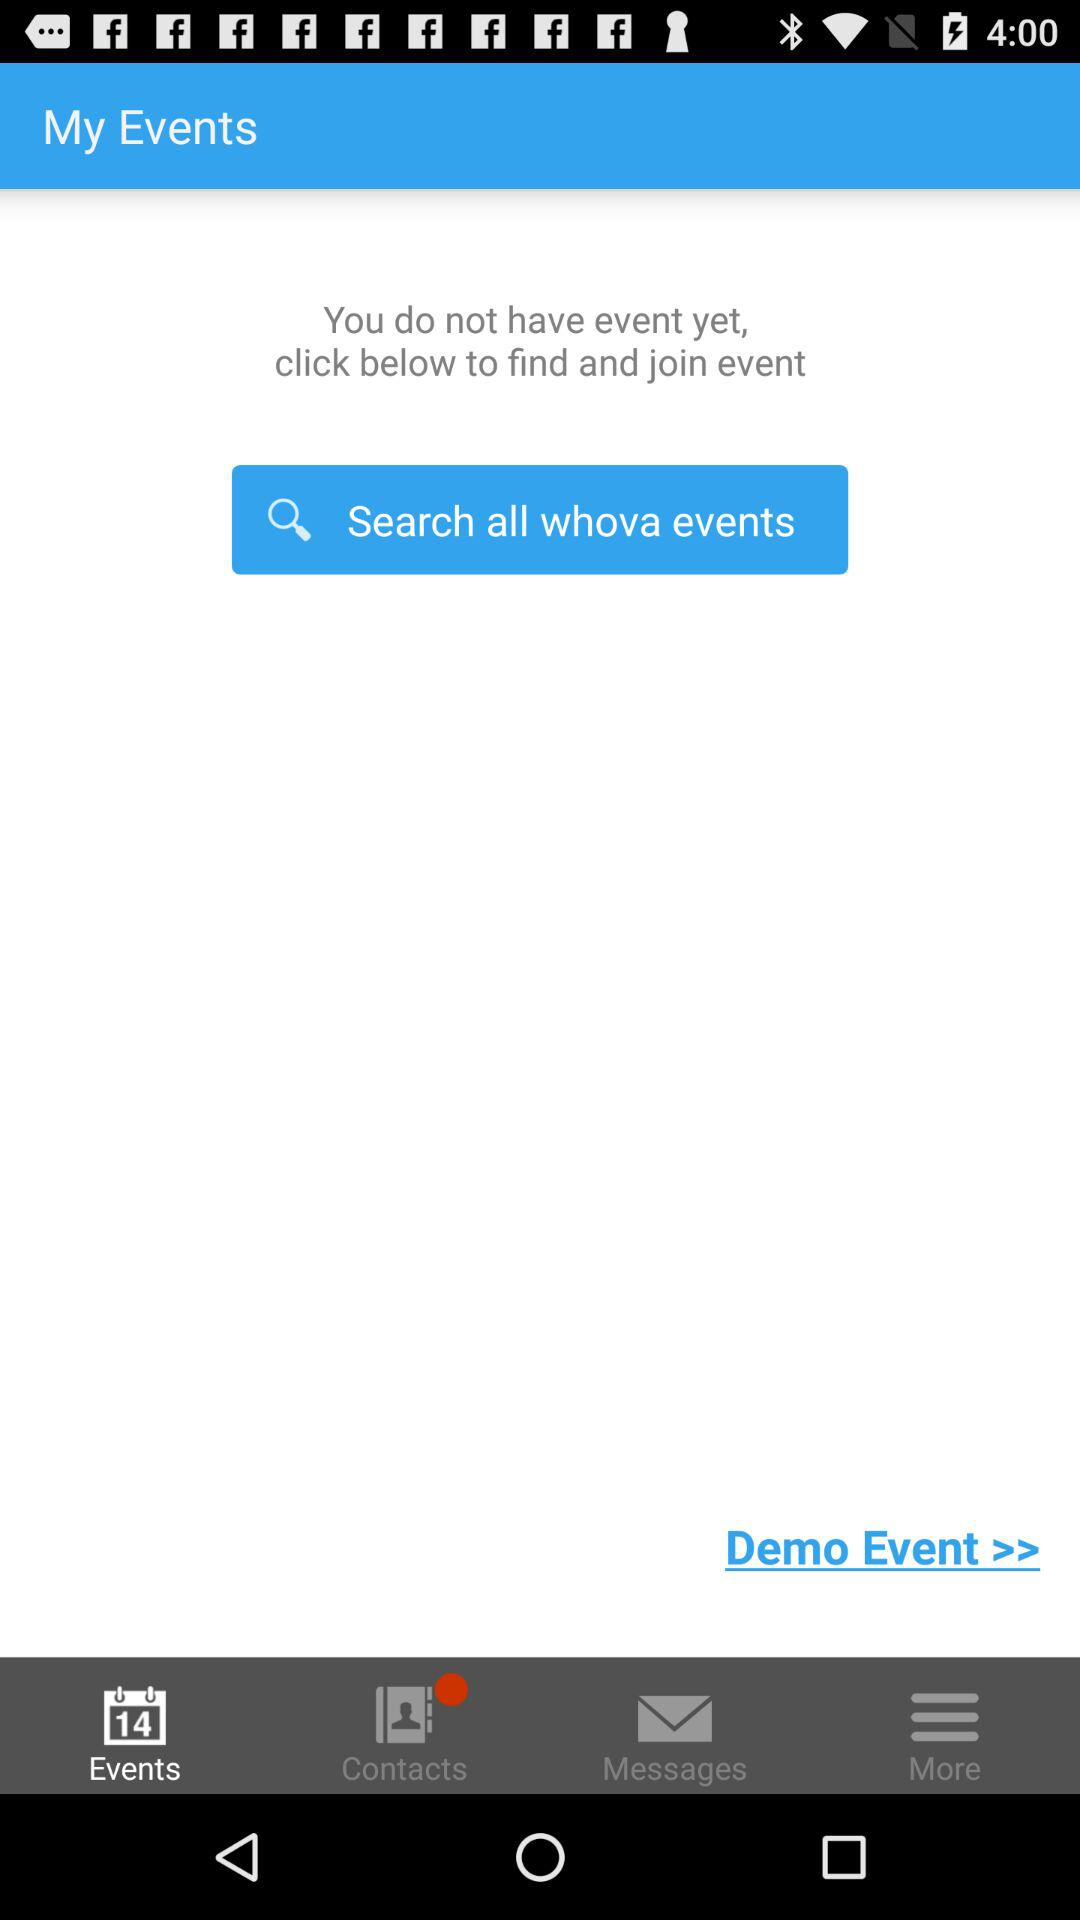How many past messages are saved?
When the provided information is insufficient, respond with <no answer>. <no answer> 